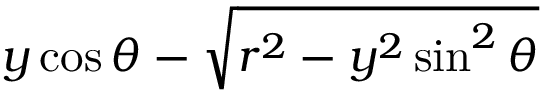Convert formula to latex. <formula><loc_0><loc_0><loc_500><loc_500>y \cos \theta - \sqrt { r ^ { 2 } - y ^ { 2 } \sin ^ { 2 } \theta }</formula> 